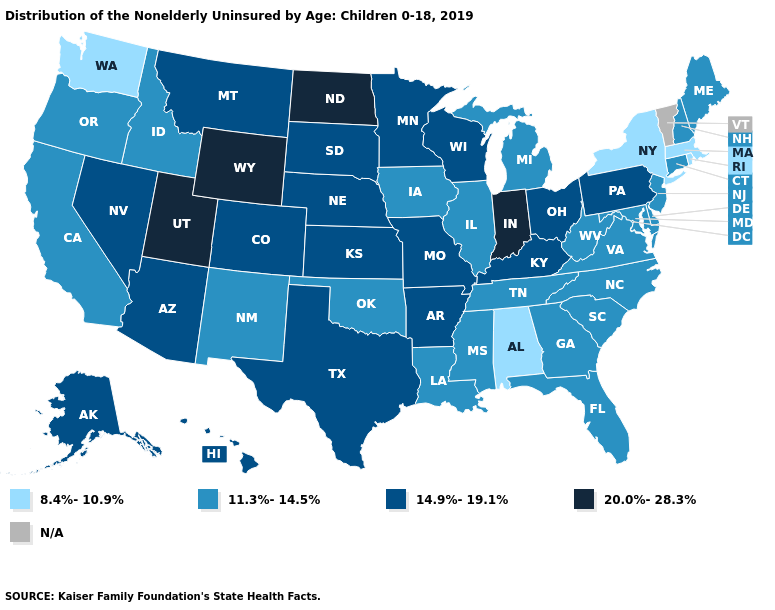Name the states that have a value in the range N/A?
Be succinct. Vermont. How many symbols are there in the legend?
Give a very brief answer. 5. What is the value of Indiana?
Answer briefly. 20.0%-28.3%. Name the states that have a value in the range N/A?
Write a very short answer. Vermont. How many symbols are there in the legend?
Write a very short answer. 5. Name the states that have a value in the range N/A?
Write a very short answer. Vermont. Name the states that have a value in the range 14.9%-19.1%?
Give a very brief answer. Alaska, Arizona, Arkansas, Colorado, Hawaii, Kansas, Kentucky, Minnesota, Missouri, Montana, Nebraska, Nevada, Ohio, Pennsylvania, South Dakota, Texas, Wisconsin. Name the states that have a value in the range N/A?
Be succinct. Vermont. What is the value of Kansas?
Give a very brief answer. 14.9%-19.1%. What is the value of Massachusetts?
Answer briefly. 8.4%-10.9%. Which states have the lowest value in the Northeast?
Short answer required. Massachusetts, New York, Rhode Island. What is the highest value in the USA?
Quick response, please. 20.0%-28.3%. What is the lowest value in the USA?
Give a very brief answer. 8.4%-10.9%. 